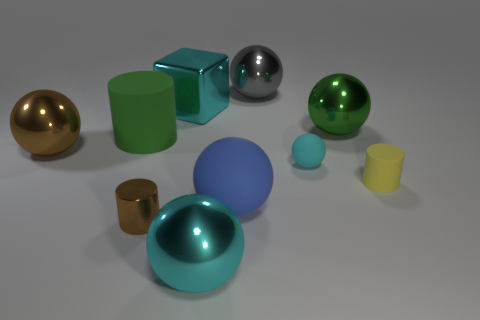Subtract all gray spheres. How many spheres are left? 5 Subtract all green balls. How many balls are left? 5 Subtract all red balls. Subtract all yellow blocks. How many balls are left? 6 Subtract all spheres. How many objects are left? 4 Add 4 big rubber objects. How many big rubber objects exist? 6 Subtract 0 purple spheres. How many objects are left? 10 Subtract all gray things. Subtract all rubber objects. How many objects are left? 5 Add 5 tiny cyan objects. How many tiny cyan objects are left? 6 